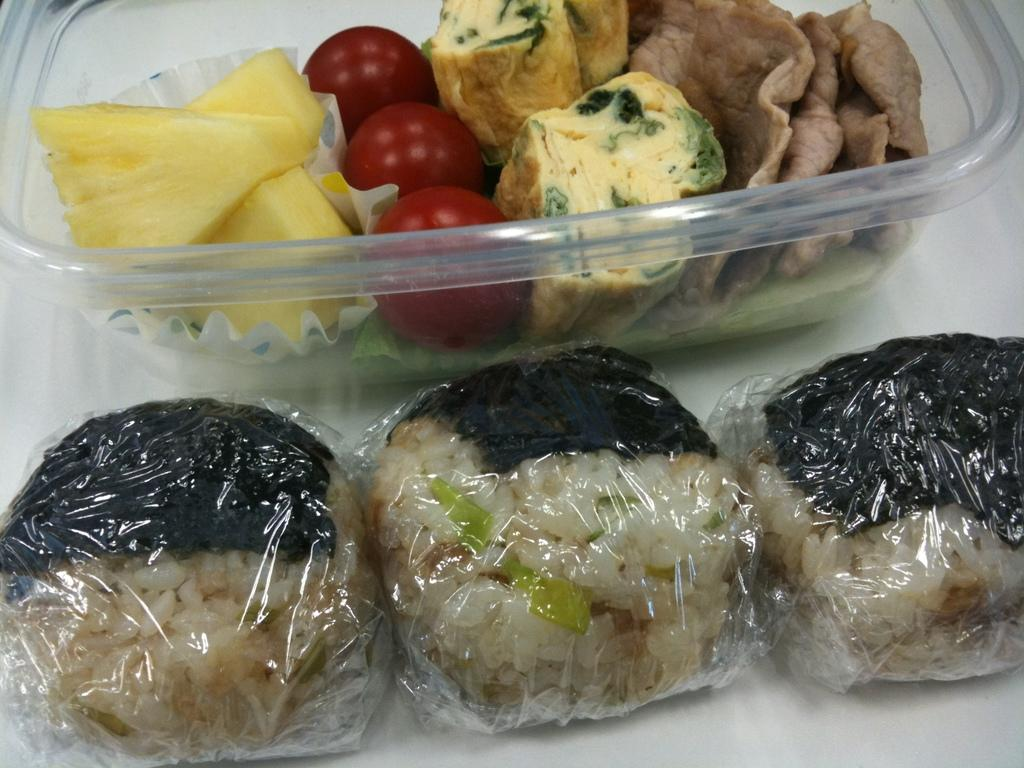What is the main object in the image? There is a tray in the image. What is on the tray? The tray contains food items. Are there any other items in the image besides the food items on the tray? Yes, there are additional items in the image that are packed. Can you observe any airplanes taking off at the airport in the image? There is no airport or airplanes visible in the image. What type of money is being exchanged in the image? There is no exchange of money or any financial transactions depicted in the image. 